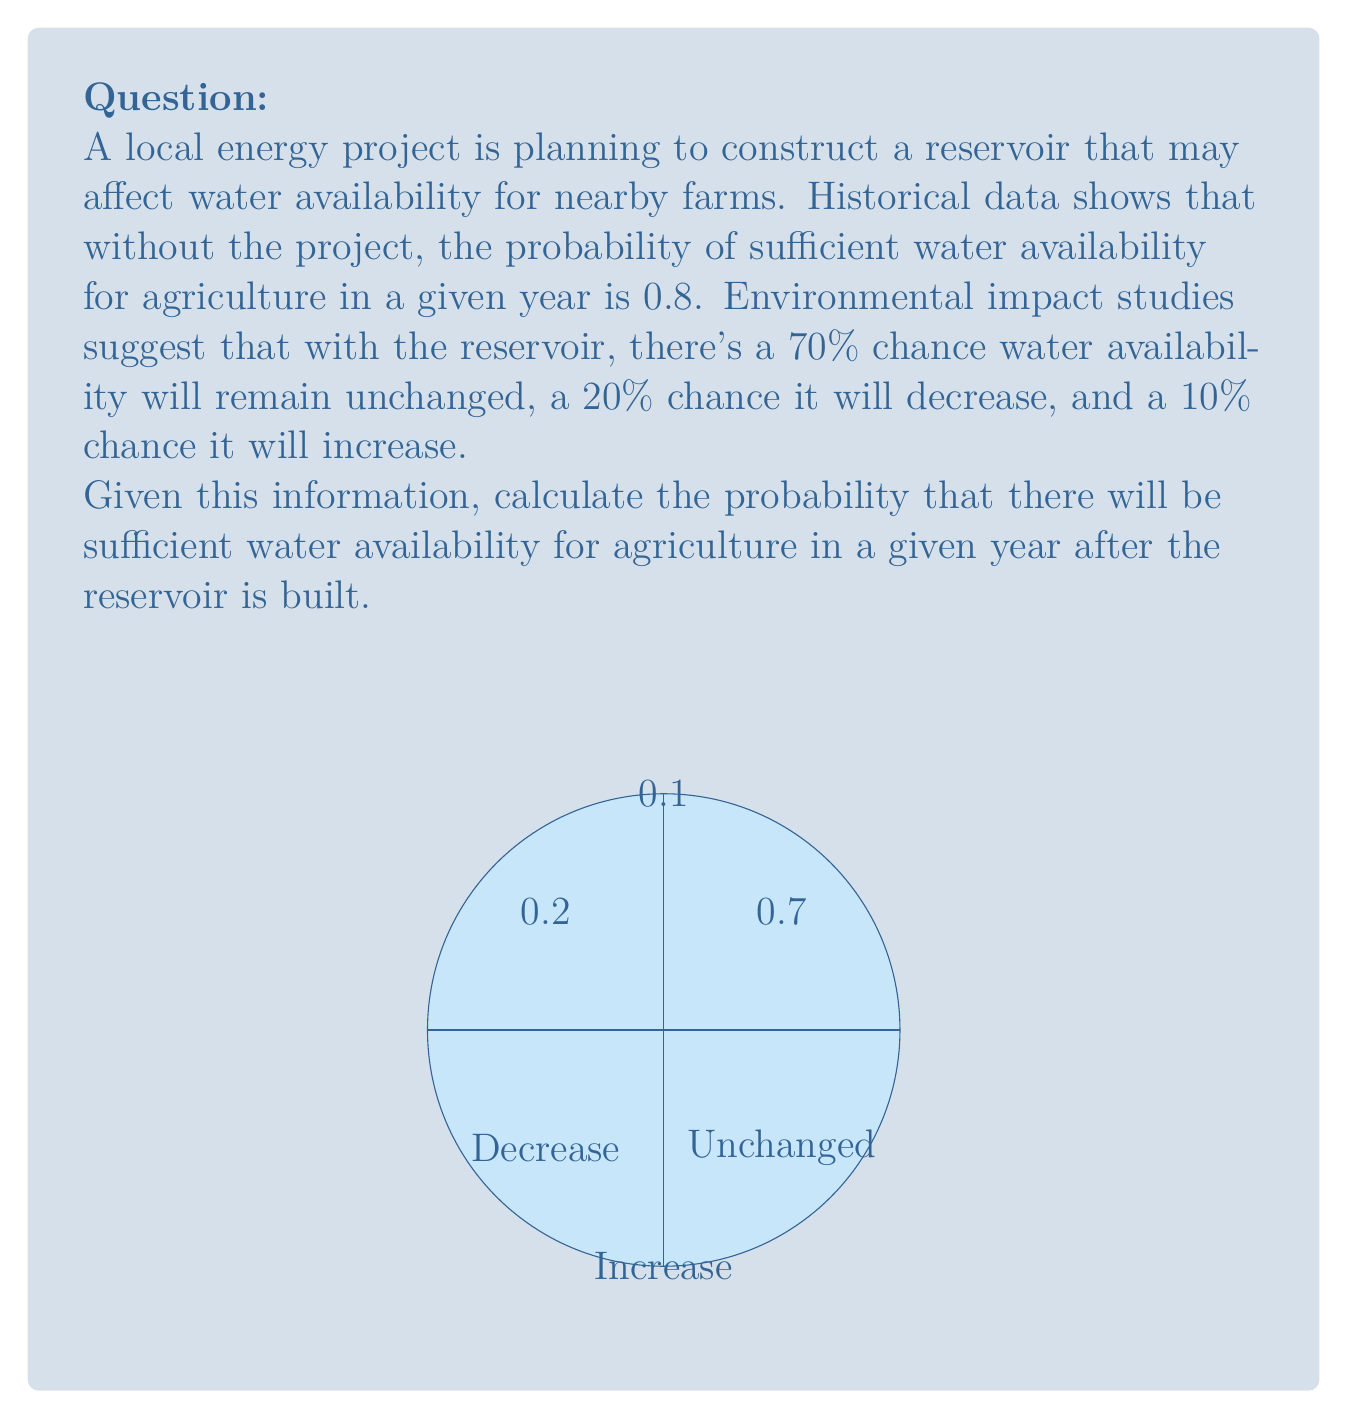Help me with this question. Let's approach this step-by-step using the law of total probability:

1) Let A be the event of sufficient water availability after the reservoir is built.
   Let U, D, and I be the events of unchanged, decreased, and increased water availability respectively.

2) We know:
   P(U) = 0.7, P(D) = 0.2, P(I) = 0.1
   P(A|U) = 0.8 (unchanged from historical data)
   P(A|D) < 0.8 (we'll assume worst case: P(A|D) = 0)
   P(A|I) = 1 (if water availability increases, it will be sufficient)

3) Using the law of total probability:
   
   $$P(A) = P(A|U)P(U) + P(A|D)P(D) + P(A|I)P(I)$$

4) Substituting the values:

   $$P(A) = 0.8 \times 0.7 + 0 \times 0.2 + 1 \times 0.1$$

5) Calculating:

   $$P(A) = 0.56 + 0 + 0.1 = 0.66$$

Therefore, the probability of sufficient water availability after the reservoir is built is 0.66 or 66%.
Answer: 0.66 